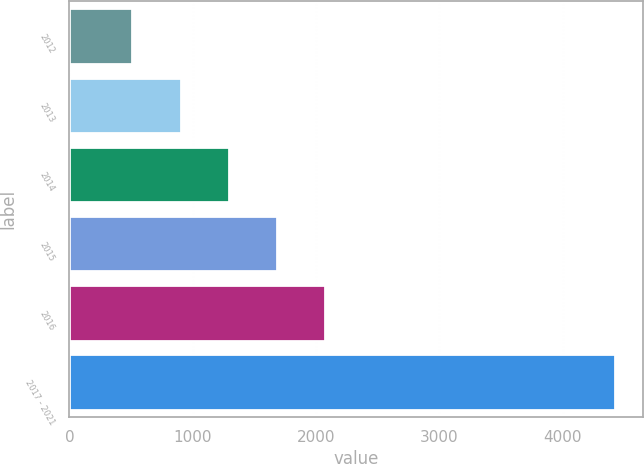Convert chart. <chart><loc_0><loc_0><loc_500><loc_500><bar_chart><fcel>2012<fcel>2013<fcel>2014<fcel>2015<fcel>2016<fcel>2017 - 2021<nl><fcel>509<fcel>900.9<fcel>1292.8<fcel>1684.7<fcel>2076.6<fcel>4428<nl></chart> 